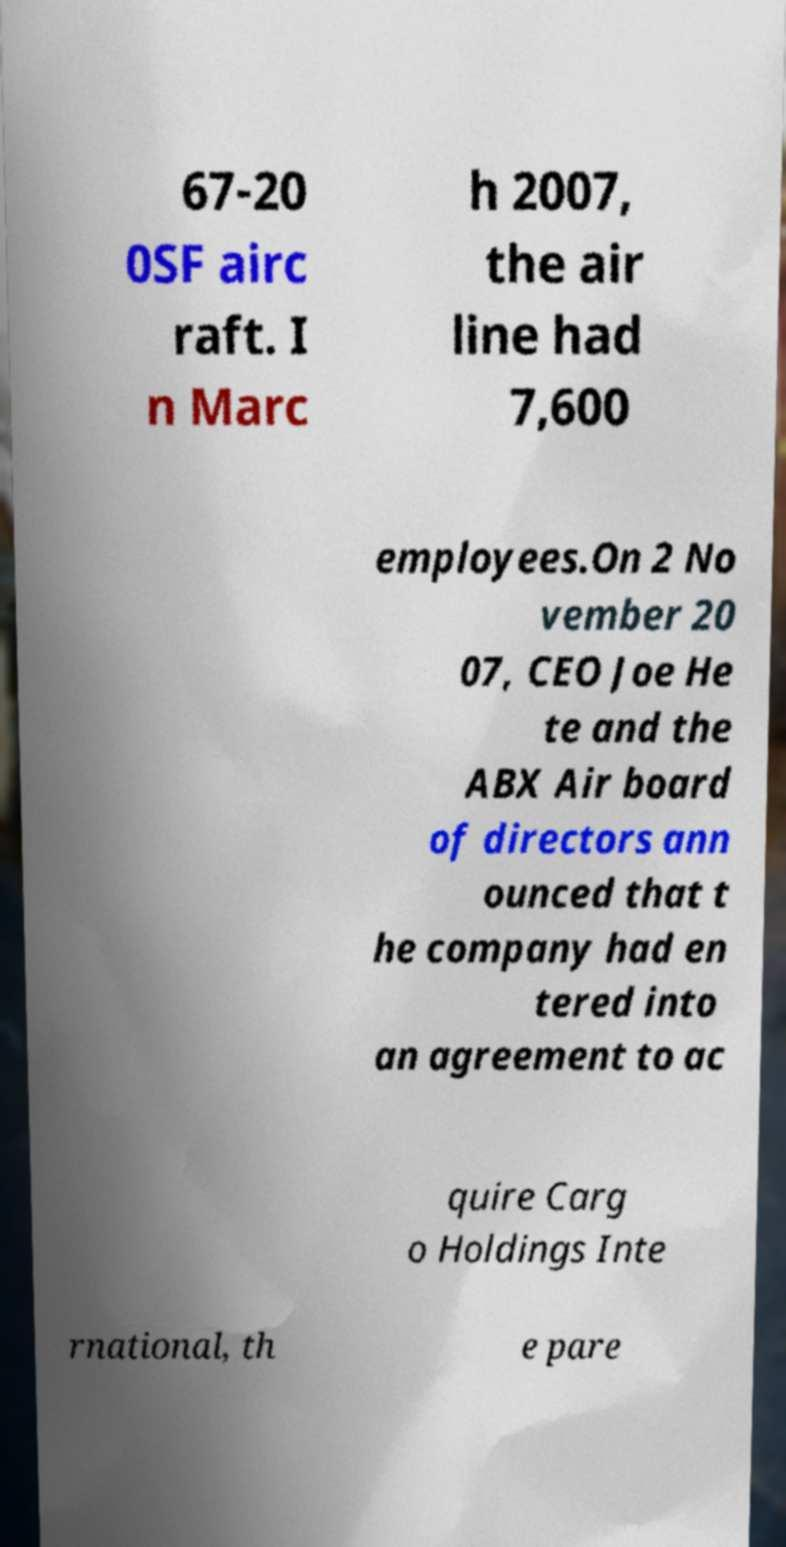For documentation purposes, I need the text within this image transcribed. Could you provide that? 67-20 0SF airc raft. I n Marc h 2007, the air line had 7,600 employees.On 2 No vember 20 07, CEO Joe He te and the ABX Air board of directors ann ounced that t he company had en tered into an agreement to ac quire Carg o Holdings Inte rnational, th e pare 